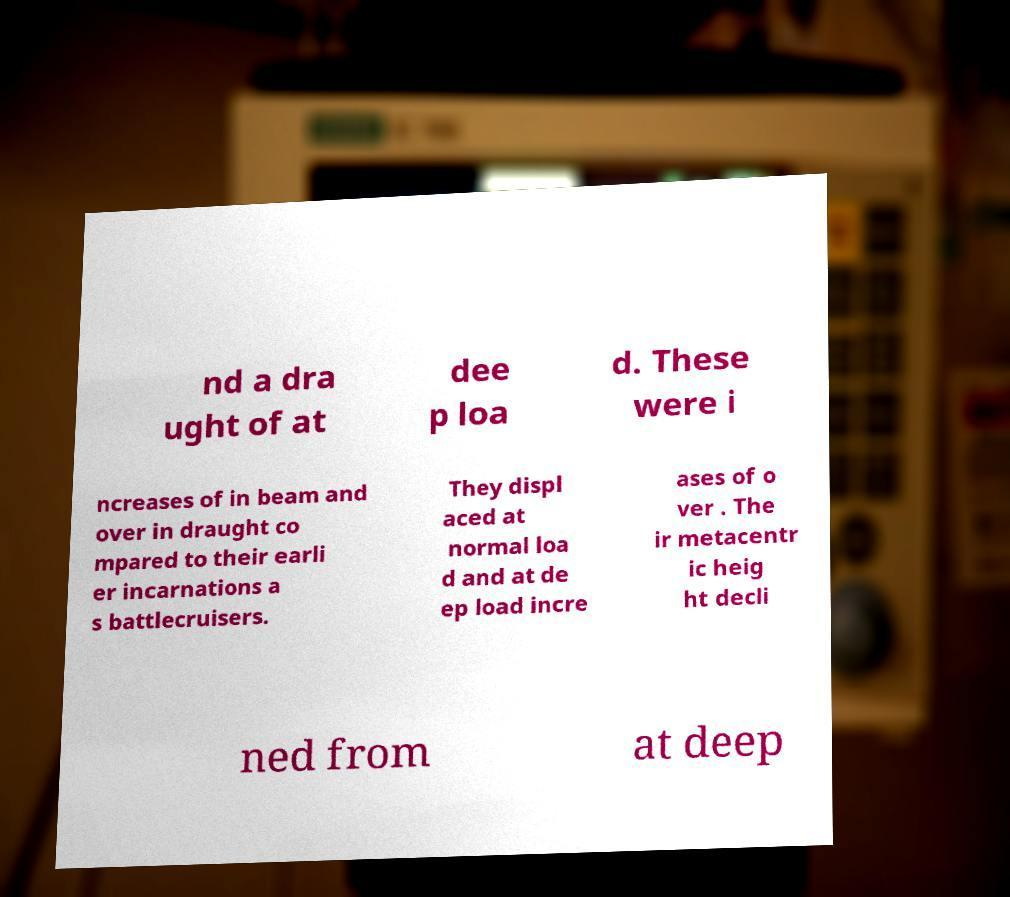Can you accurately transcribe the text from the provided image for me? nd a dra ught of at dee p loa d. These were i ncreases of in beam and over in draught co mpared to their earli er incarnations a s battlecruisers. They displ aced at normal loa d and at de ep load incre ases of o ver . The ir metacentr ic heig ht decli ned from at deep 